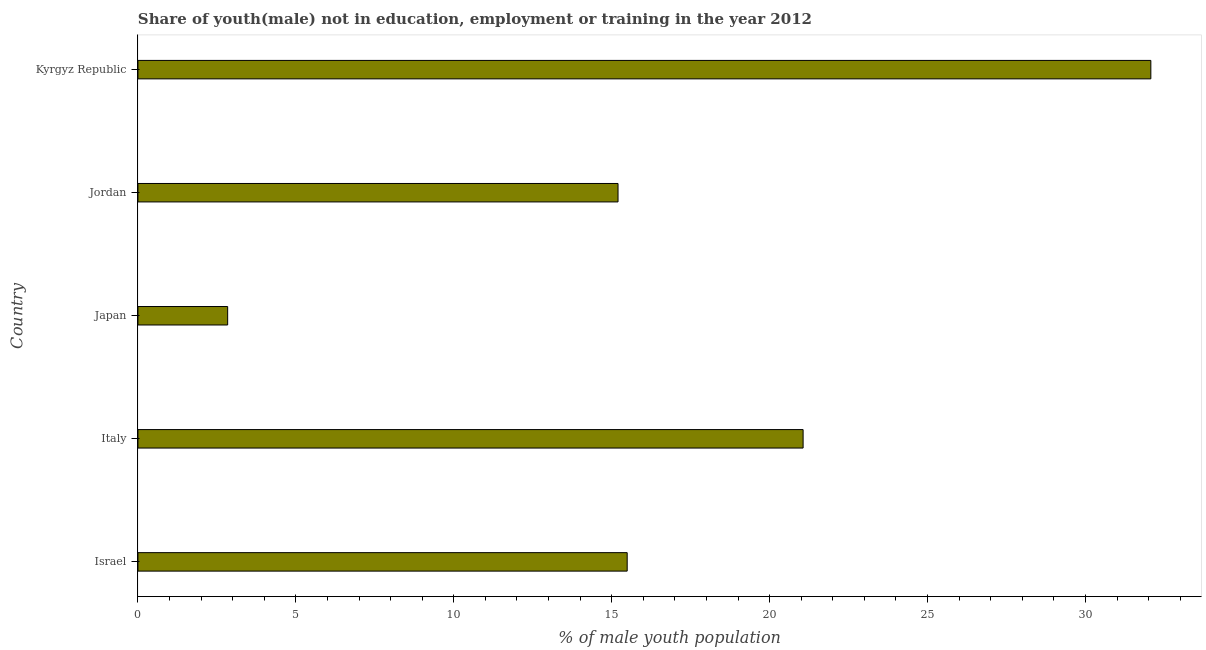Does the graph contain any zero values?
Provide a succinct answer. No. Does the graph contain grids?
Keep it short and to the point. No. What is the title of the graph?
Your response must be concise. Share of youth(male) not in education, employment or training in the year 2012. What is the label or title of the X-axis?
Make the answer very short. % of male youth population. What is the label or title of the Y-axis?
Make the answer very short. Country. What is the unemployed male youth population in Kyrgyz Republic?
Offer a terse response. 32.07. Across all countries, what is the maximum unemployed male youth population?
Provide a short and direct response. 32.07. Across all countries, what is the minimum unemployed male youth population?
Keep it short and to the point. 2.84. In which country was the unemployed male youth population maximum?
Offer a very short reply. Kyrgyz Republic. In which country was the unemployed male youth population minimum?
Your answer should be very brief. Japan. What is the sum of the unemployed male youth population?
Provide a succinct answer. 86.66. What is the difference between the unemployed male youth population in Italy and Kyrgyz Republic?
Provide a succinct answer. -11.01. What is the average unemployed male youth population per country?
Give a very brief answer. 17.33. What is the median unemployed male youth population?
Your answer should be compact. 15.49. In how many countries, is the unemployed male youth population greater than 19 %?
Provide a short and direct response. 2. What is the ratio of the unemployed male youth population in Israel to that in Italy?
Give a very brief answer. 0.74. What is the difference between the highest and the second highest unemployed male youth population?
Offer a very short reply. 11.01. Is the sum of the unemployed male youth population in Italy and Japan greater than the maximum unemployed male youth population across all countries?
Keep it short and to the point. No. What is the difference between the highest and the lowest unemployed male youth population?
Offer a very short reply. 29.23. How many bars are there?
Offer a terse response. 5. Are all the bars in the graph horizontal?
Your response must be concise. Yes. How many countries are there in the graph?
Ensure brevity in your answer.  5. What is the difference between two consecutive major ticks on the X-axis?
Offer a terse response. 5. Are the values on the major ticks of X-axis written in scientific E-notation?
Keep it short and to the point. No. What is the % of male youth population of Israel?
Ensure brevity in your answer.  15.49. What is the % of male youth population in Italy?
Offer a very short reply. 21.06. What is the % of male youth population in Japan?
Offer a very short reply. 2.84. What is the % of male youth population of Jordan?
Provide a short and direct response. 15.2. What is the % of male youth population in Kyrgyz Republic?
Your answer should be very brief. 32.07. What is the difference between the % of male youth population in Israel and Italy?
Offer a terse response. -5.57. What is the difference between the % of male youth population in Israel and Japan?
Make the answer very short. 12.65. What is the difference between the % of male youth population in Israel and Jordan?
Provide a succinct answer. 0.29. What is the difference between the % of male youth population in Israel and Kyrgyz Republic?
Ensure brevity in your answer.  -16.58. What is the difference between the % of male youth population in Italy and Japan?
Your answer should be very brief. 18.22. What is the difference between the % of male youth population in Italy and Jordan?
Your answer should be compact. 5.86. What is the difference between the % of male youth population in Italy and Kyrgyz Republic?
Make the answer very short. -11.01. What is the difference between the % of male youth population in Japan and Jordan?
Give a very brief answer. -12.36. What is the difference between the % of male youth population in Japan and Kyrgyz Republic?
Your answer should be very brief. -29.23. What is the difference between the % of male youth population in Jordan and Kyrgyz Republic?
Provide a succinct answer. -16.87. What is the ratio of the % of male youth population in Israel to that in Italy?
Give a very brief answer. 0.74. What is the ratio of the % of male youth population in Israel to that in Japan?
Your answer should be compact. 5.45. What is the ratio of the % of male youth population in Israel to that in Kyrgyz Republic?
Your answer should be very brief. 0.48. What is the ratio of the % of male youth population in Italy to that in Japan?
Ensure brevity in your answer.  7.42. What is the ratio of the % of male youth population in Italy to that in Jordan?
Offer a very short reply. 1.39. What is the ratio of the % of male youth population in Italy to that in Kyrgyz Republic?
Offer a very short reply. 0.66. What is the ratio of the % of male youth population in Japan to that in Jordan?
Give a very brief answer. 0.19. What is the ratio of the % of male youth population in Japan to that in Kyrgyz Republic?
Your answer should be compact. 0.09. What is the ratio of the % of male youth population in Jordan to that in Kyrgyz Republic?
Keep it short and to the point. 0.47. 